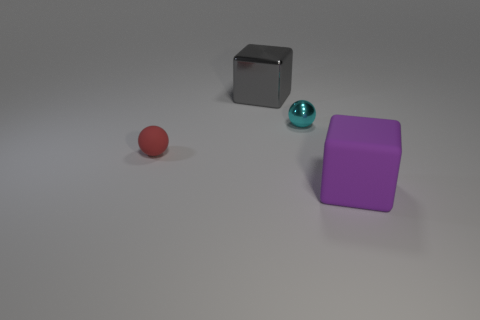There is a thing that is both right of the rubber sphere and to the left of the small metallic object; what color is it?
Ensure brevity in your answer.  Gray. How many small objects are green objects or balls?
Your answer should be very brief. 2. There is a red matte object that is the same shape as the tiny metal thing; what is its size?
Offer a very short reply. Small. What is the shape of the red matte object?
Your response must be concise. Sphere. Are the cyan object and the big cube that is left of the small cyan shiny object made of the same material?
Provide a succinct answer. Yes. What number of matte objects are either cyan spheres or tiny red spheres?
Make the answer very short. 1. What size is the block that is in front of the gray thing?
Make the answer very short. Large. What is the size of the sphere that is made of the same material as the purple cube?
Offer a very short reply. Small. Is there a large shiny block?
Provide a short and direct response. Yes. There is a small matte thing; does it have the same shape as the small object that is behind the small matte sphere?
Provide a short and direct response. Yes. 